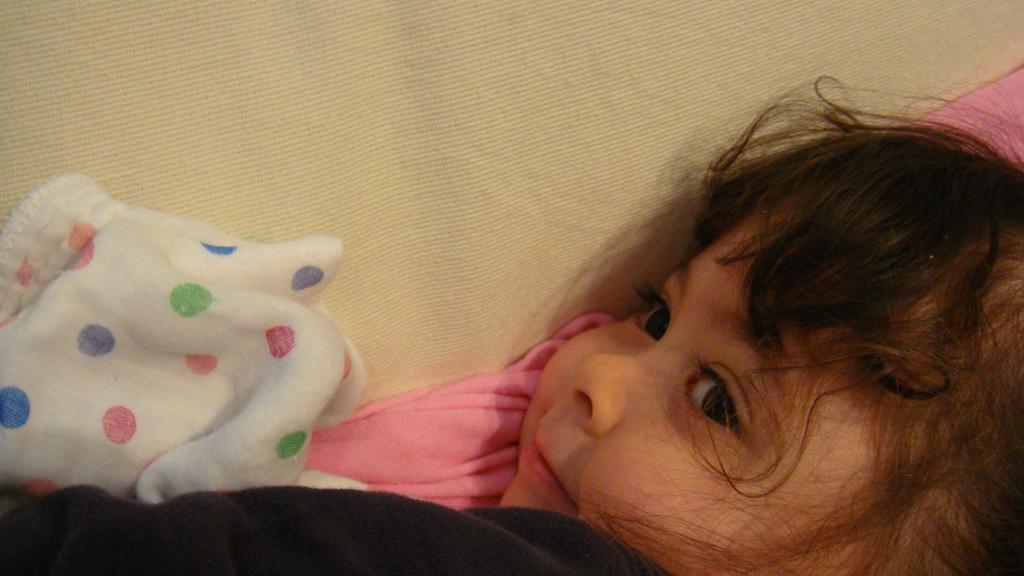Can you describe this image briefly? In this image, we can see a kid and there is a bed sheet. 